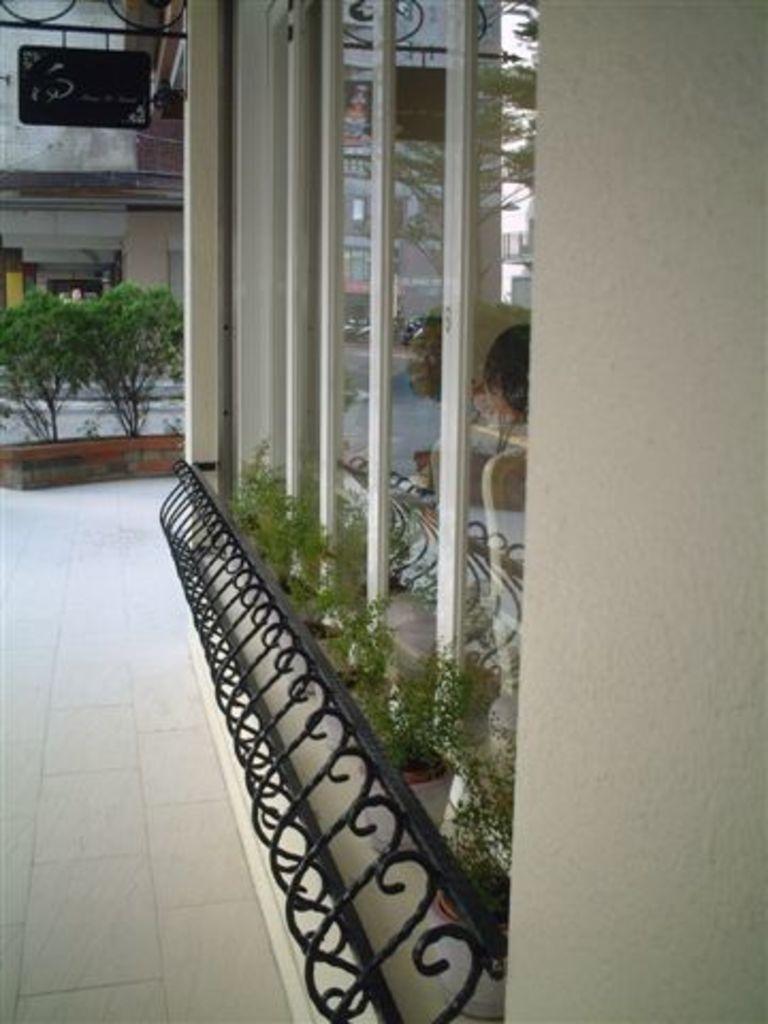In one or two sentences, can you explain what this image depicts? In this image we can see buildings, plants, iron objects, glass objects, name board, railing and other objects. At the bottom of the image there is the floor. On the right side of the image there is a wall. 